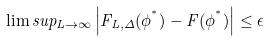<formula> <loc_0><loc_0><loc_500><loc_500>\lim s u p _ { L \to \infty } \left | F _ { L , \Delta } ( \phi ^ { ^ { * } } ) - F ( \phi ^ { ^ { * } } ) \right | \leq \epsilon</formula> 